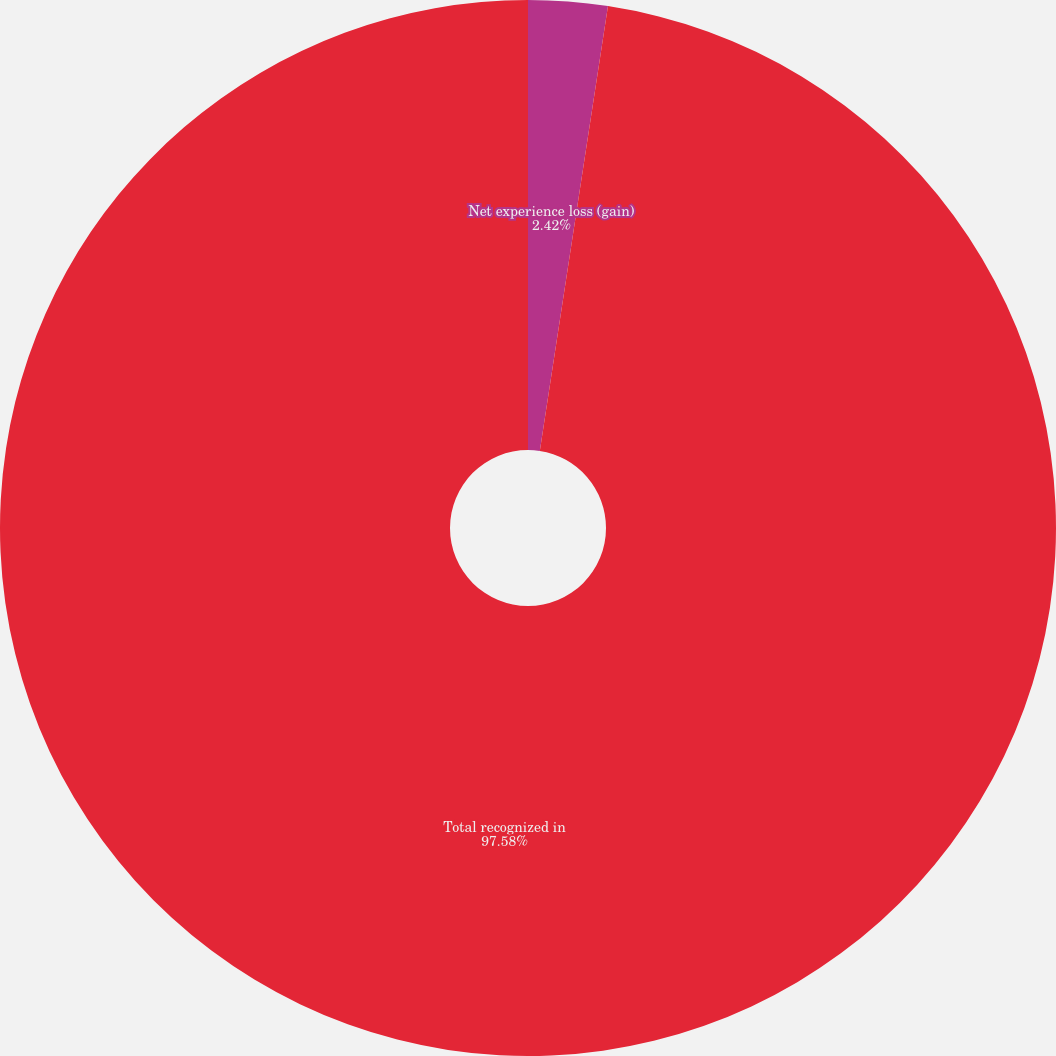Convert chart to OTSL. <chart><loc_0><loc_0><loc_500><loc_500><pie_chart><fcel>Net experience loss (gain)<fcel>Total recognized in<nl><fcel>2.42%<fcel>97.58%<nl></chart> 